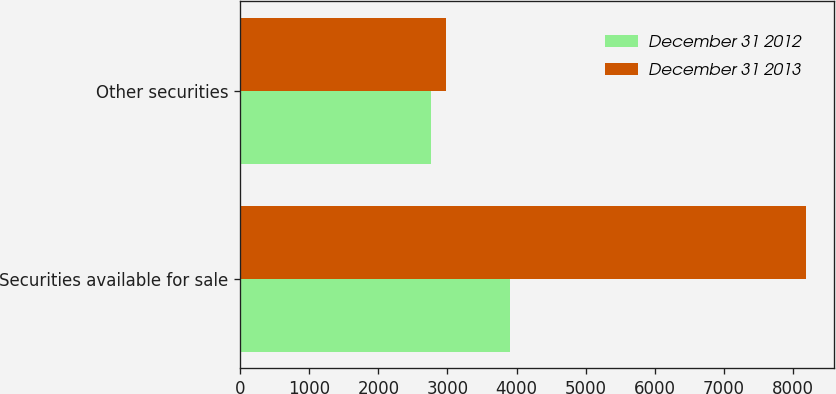Convert chart. <chart><loc_0><loc_0><loc_500><loc_500><stacked_bar_chart><ecel><fcel>Securities available for sale<fcel>Other securities<nl><fcel>December 31 2012<fcel>3907<fcel>2766<nl><fcel>December 31 2013<fcel>8180<fcel>2985<nl></chart> 